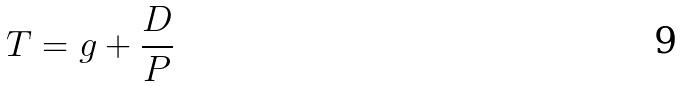<formula> <loc_0><loc_0><loc_500><loc_500>T = g + \frac { D } { P }</formula> 